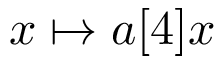Convert formula to latex. <formula><loc_0><loc_0><loc_500><loc_500>x \mapsto a [ 4 ] x</formula> 